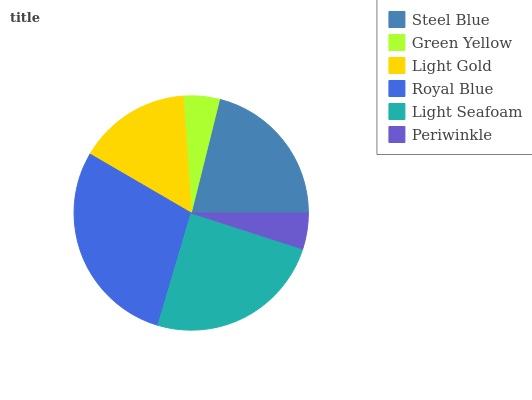Is Periwinkle the minimum?
Answer yes or no. Yes. Is Royal Blue the maximum?
Answer yes or no. Yes. Is Green Yellow the minimum?
Answer yes or no. No. Is Green Yellow the maximum?
Answer yes or no. No. Is Steel Blue greater than Green Yellow?
Answer yes or no. Yes. Is Green Yellow less than Steel Blue?
Answer yes or no. Yes. Is Green Yellow greater than Steel Blue?
Answer yes or no. No. Is Steel Blue less than Green Yellow?
Answer yes or no. No. Is Steel Blue the high median?
Answer yes or no. Yes. Is Light Gold the low median?
Answer yes or no. Yes. Is Periwinkle the high median?
Answer yes or no. No. Is Periwinkle the low median?
Answer yes or no. No. 